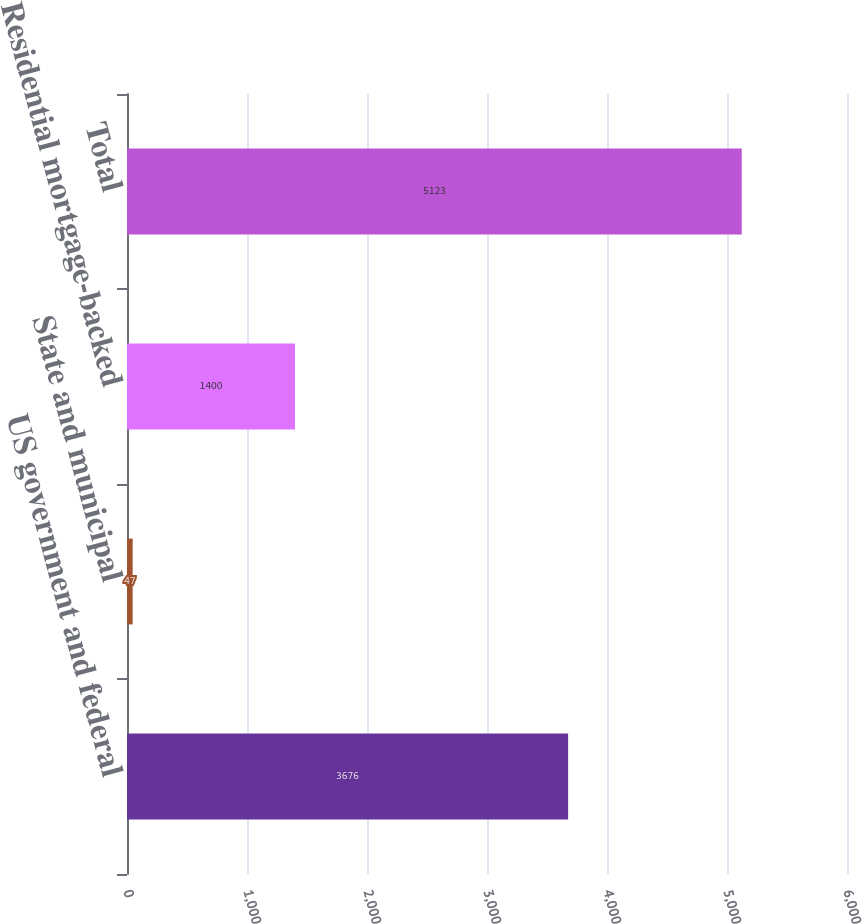Convert chart to OTSL. <chart><loc_0><loc_0><loc_500><loc_500><bar_chart><fcel>US government and federal<fcel>State and municipal<fcel>Residential mortgage-backed<fcel>Total<nl><fcel>3676<fcel>47<fcel>1400<fcel>5123<nl></chart> 